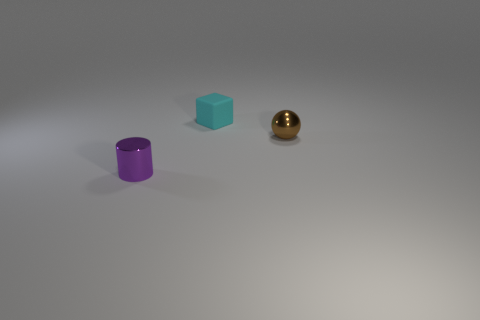Add 3 small cubes. How many objects exist? 6 Subtract all cubes. How many objects are left? 2 Subtract all big yellow cubes. Subtract all cyan blocks. How many objects are left? 2 Add 3 tiny purple metal cylinders. How many tiny purple metal cylinders are left? 4 Add 2 small cyan things. How many small cyan things exist? 3 Subtract 0 blue cubes. How many objects are left? 3 